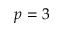<formula> <loc_0><loc_0><loc_500><loc_500>p = 3</formula> 